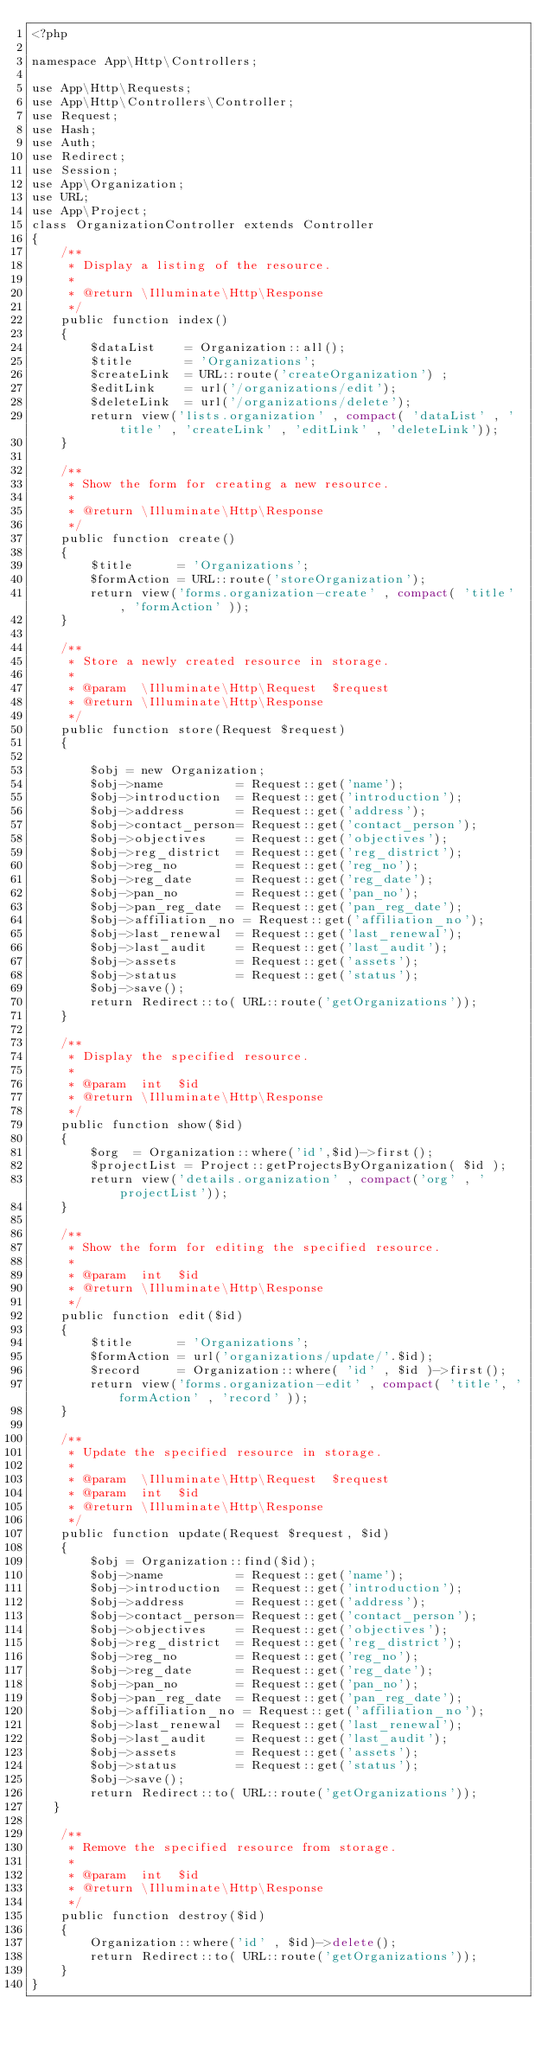Convert code to text. <code><loc_0><loc_0><loc_500><loc_500><_PHP_><?php

namespace App\Http\Controllers;

use App\Http\Requests;
use App\Http\Controllers\Controller;
use Request;
use Hash;
use Auth;
use Redirect;
use Session;
use App\Organization;
use URL;
use App\Project;
class OrganizationController extends Controller
{
    /**
     * Display a listing of the resource.
     *
     * @return \Illuminate\Http\Response
     */
    public function index()
    {
        $dataList    = Organization::all();
        $title       = 'Organizations';
        $createLink  = URL::route('createOrganization') ;
        $editLink    = url('/organizations/edit');
        $deleteLink  = url('/organizations/delete');
        return view('lists.organization' , compact( 'dataList' , 'title' , 'createLink' , 'editLink' , 'deleteLink'));
    }

    /**
     * Show the form for creating a new resource.
     *
     * @return \Illuminate\Http\Response
     */
    public function create()
    {
        $title      = 'Organizations';
        $formAction = URL::route('storeOrganization');
        return view('forms.organization-create' , compact( 'title' , 'formAction' ));
    }

    /**
     * Store a newly created resource in storage.
     *
     * @param  \Illuminate\Http\Request  $request
     * @return \Illuminate\Http\Response
     */
    public function store(Request $request)
    {
        
        $obj = new Organization;
        $obj->name          = Request::get('name');
        $obj->introduction  = Request::get('introduction');
        $obj->address       = Request::get('address');
        $obj->contact_person= Request::get('contact_person');
        $obj->objectives    = Request::get('objectives');
        $obj->reg_district  = Request::get('reg_district');
        $obj->reg_no        = Request::get('reg_no');
        $obj->reg_date      = Request::get('reg_date');
        $obj->pan_no        = Request::get('pan_no');
        $obj->pan_reg_date  = Request::get('pan_reg_date');
        $obj->affiliation_no = Request::get('affiliation_no');
        $obj->last_renewal  = Request::get('last_renewal');
        $obj->last_audit    = Request::get('last_audit');
        $obj->assets        = Request::get('assets');
        $obj->status        = Request::get('status');
        $obj->save();
        return Redirect::to( URL::route('getOrganizations'));
    }

    /**
     * Display the specified resource.
     *
     * @param  int  $id
     * @return \Illuminate\Http\Response
     */
    public function show($id)
    {
        $org  = Organization::where('id',$id)->first();
        $projectList = Project::getProjectsByOrganization( $id );
        return view('details.organization' , compact('org' , 'projectList'));
    }

    /**
     * Show the form for editing the specified resource.
     *
     * @param  int  $id
     * @return \Illuminate\Http\Response
     */
    public function edit($id)
    {
        $title      = 'Organizations';
        $formAction = url('organizations/update/'.$id);
        $record     = Organization::where( 'id' , $id )->first();
        return view('forms.organization-edit' , compact( 'title', 'formAction' , 'record' ));
    }

    /**
     * Update the specified resource in storage.
     *
     * @param  \Illuminate\Http\Request  $request
     * @param  int  $id
     * @return \Illuminate\Http\Response
     */
    public function update(Request $request, $id)
    { 
        $obj = Organization::find($id); 
        $obj->name          = Request::get('name');
        $obj->introduction  = Request::get('introduction');
        $obj->address       = Request::get('address');
        $obj->contact_person= Request::get('contact_person');
        $obj->objectives    = Request::get('objectives');
        $obj->reg_district  = Request::get('reg_district');
        $obj->reg_no        = Request::get('reg_no');
        $obj->reg_date      = Request::get('reg_date');
        $obj->pan_no        = Request::get('pan_no');
        $obj->pan_reg_date  = Request::get('pan_reg_date');
        $obj->affiliation_no = Request::get('affiliation_no');
        $obj->last_renewal  = Request::get('last_renewal');
        $obj->last_audit    = Request::get('last_audit');
        $obj->assets        = Request::get('assets');
        $obj->status        = Request::get('status');
        $obj->save();
        return Redirect::to( URL::route('getOrganizations'));
   }

    /**
     * Remove the specified resource from storage.
     *
     * @param  int  $id
     * @return \Illuminate\Http\Response
     */
    public function destroy($id)
    {
        Organization::where('id' , $id)->delete();
        return Redirect::to( URL::route('getOrganizations'));
    }
}
</code> 